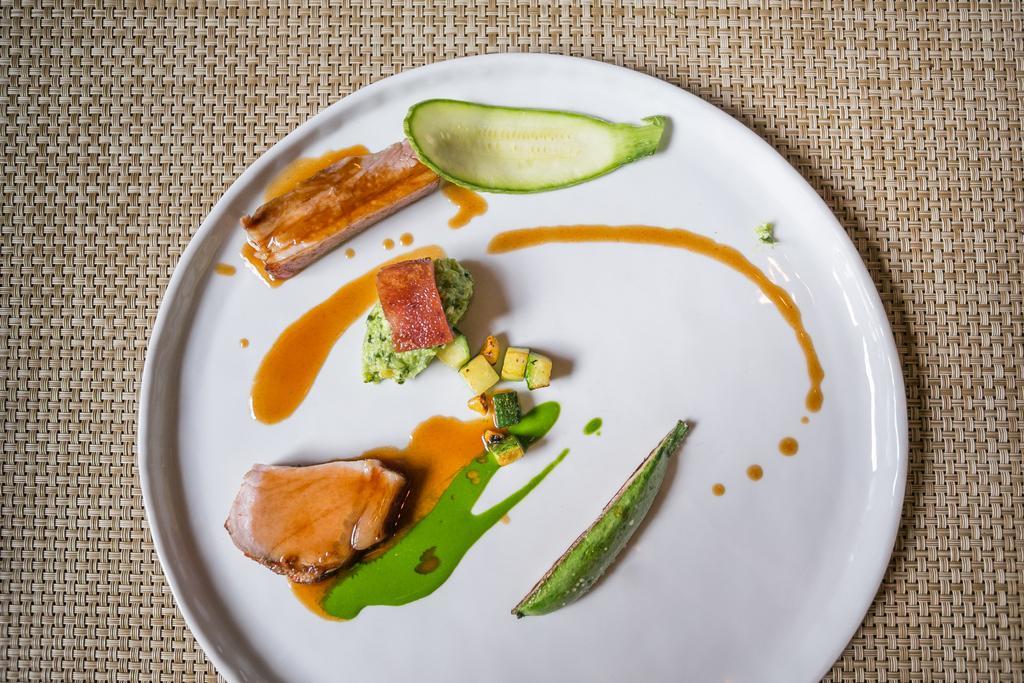Can you describe this image briefly? In this picture there is a food on the white plate. At the bottom there is a table mat. 